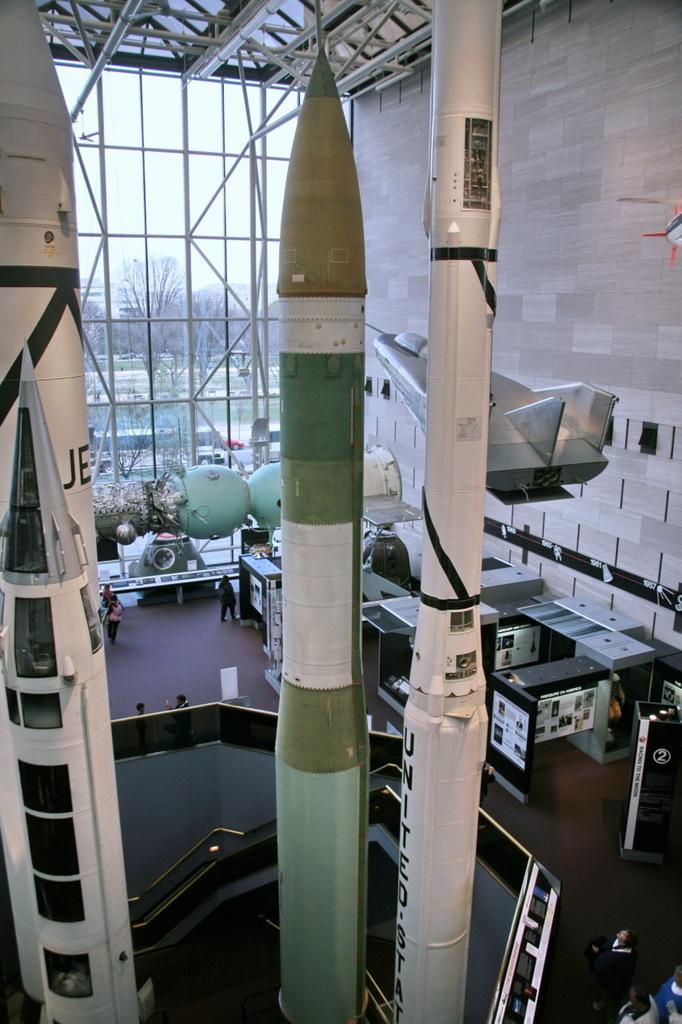What type of weapons are present in the image? There are missiles in the image. What type of equipment can be seen in the image? There are machines in the image. What type of furniture is present in the image? There are tables in the image. What type of structure is visible in the image? There is a wall in the image. Who is present in the image? There is a group of people in the image. What type of natural environment is visible in the background of the image? There are trees and water visible in the background of the image. What is visible in the sky in the background of the image? The sky is visible in the background of the image. What time of day does the image appear to be taken? The image appears to be taken during the day. How many dogs are present in the image? There are no dogs present in the image. What type of gun is being used by the group of people in the image? There is no gun present in the image. What type of lumber is being used to construct the wall in the image? There is no lumber visible in the image; only a wall is present. 